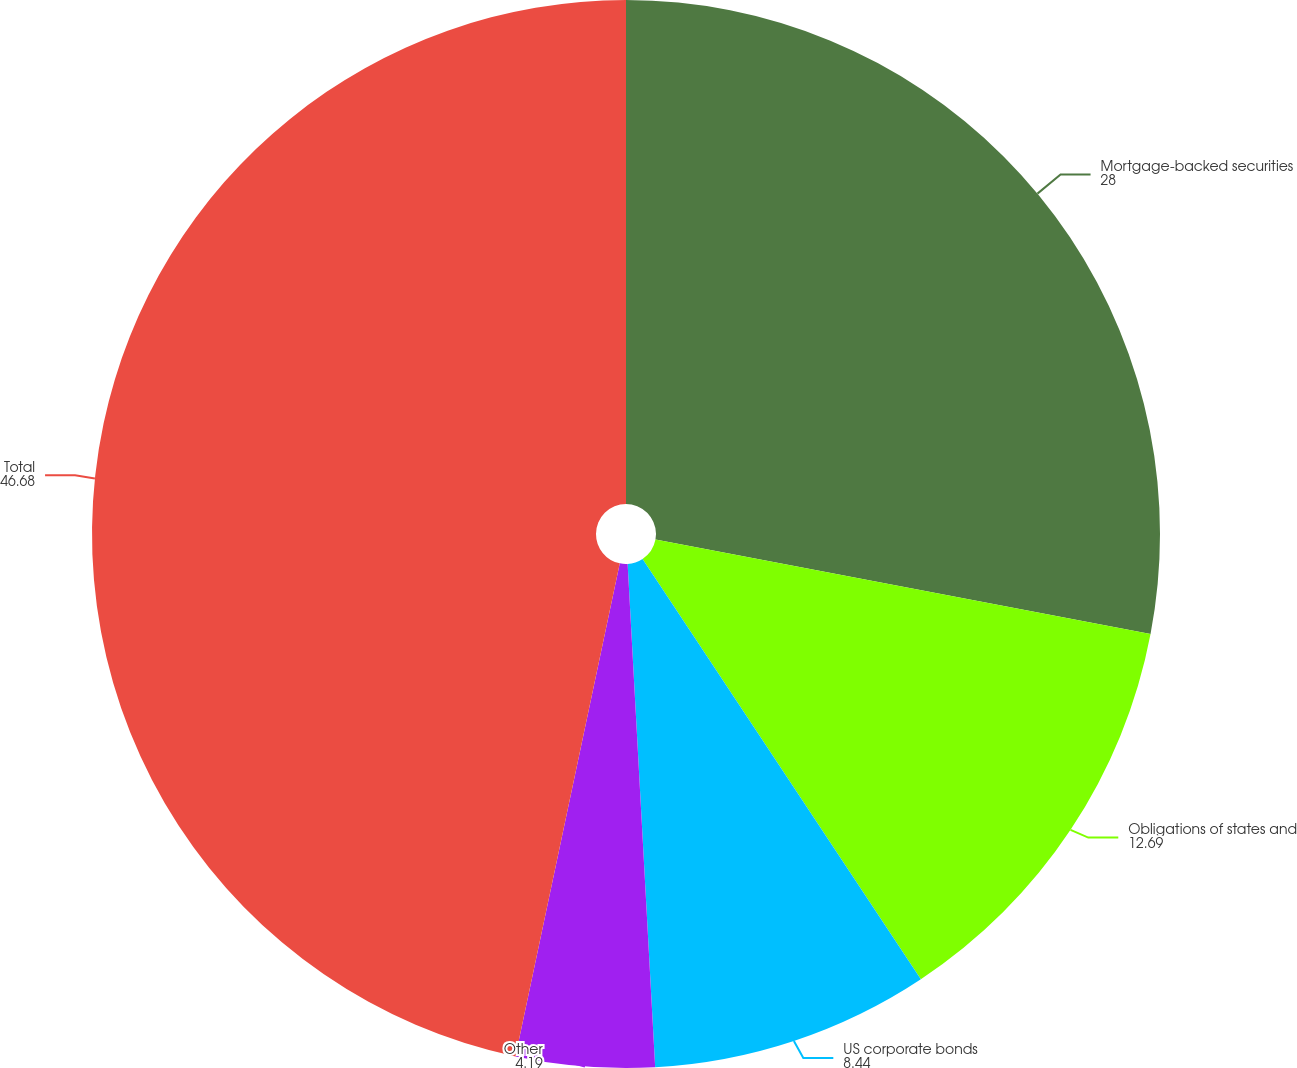Convert chart. <chart><loc_0><loc_0><loc_500><loc_500><pie_chart><fcel>Mortgage-backed securities<fcel>Obligations of states and<fcel>US corporate bonds<fcel>Other<fcel>Total<nl><fcel>28.0%<fcel>12.69%<fcel>8.44%<fcel>4.19%<fcel>46.68%<nl></chart> 